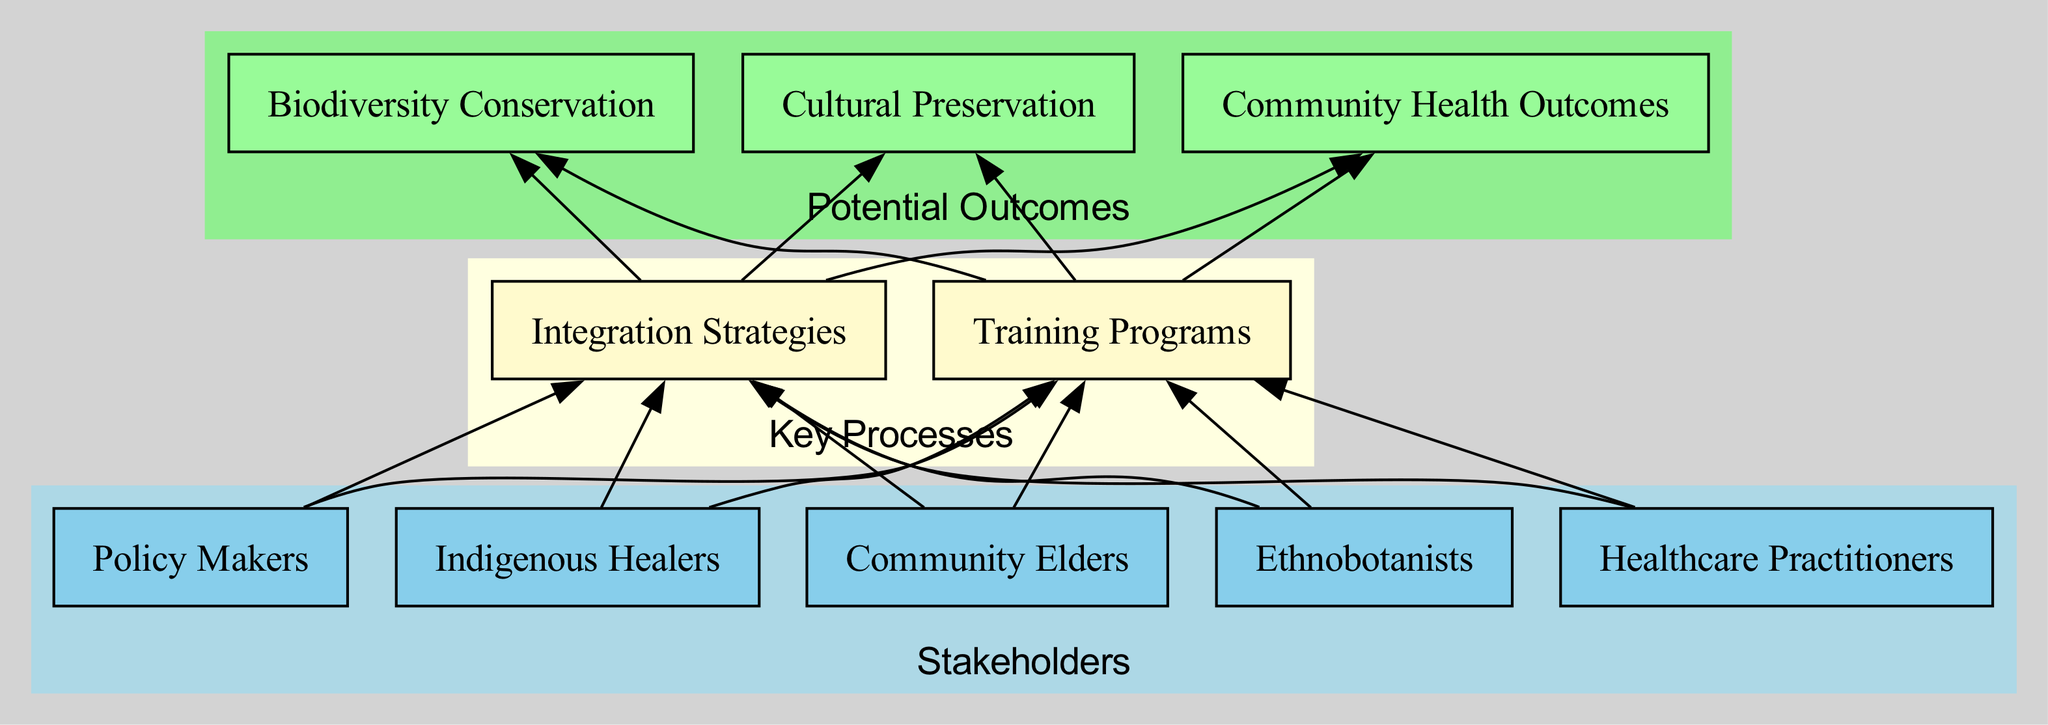What are the stakeholders identified in the diagram? The diagram categorizes certain entities as stakeholders, which include Indigenous Healers, Community Elders, Ethnobotanists, Healthcare Practitioners, and Policy Makers. These elements can be found in the 'Stakeholders' section.
Answer: Indigenous Healers, Community Elders, Ethnobotanists, Healthcare Practitioners, Policy Makers How many potential outcomes are listed in the diagram? The diagram presents three potential outcomes: Community Health Outcomes, Biodiversity Conservation, and Cultural Preservation. By counting these elements found in the 'Potential Outcomes' section, we find a total of three.
Answer: 3 Which key process connects indigenous healers to potential outcomes? The connection from Indigenous Healers occurs through 'Integration Strategies,' which serves as a bridge to the potential outcomes. The edge from 'Indigenous Healers' towards 'Integration Strategies' directs the flow towards potential outcomes.
Answer: Integration Strategies What is the role of Policy Makers in this flow chart? Policy Makers influence the process by developing regulations and guidelines for integrating traditional practices, which connects to key processes and subsequently leads to potential outcomes. Their positioning indicates a guiding function in the integration strategy.
Answer: Regulations and guidelines Which potential outcome directly relates to training programs? The 'Training Programs' key process links to three potential outcomes, but the most direct relation established is with 'Community Health Outcomes,' as training healthcare practitioners enhances health in the community.
Answer: Community Health Outcomes How many edges connect stakeholders to key processes? Each of the five stakeholders connects to the two key processes by one edge each, producing a total of 10 edges connecting stakeholders to key processes. The relationships are structurally laid out showing direct connections.
Answer: 10 What is the significance of the arrow direction in the diagram? The arrow direction illustrates a bottom-up approach, indicating the flow from stakeholders to key processes and then to potential outcomes, emphasizing a directional influence in integrating indigenous practices into healthcare.
Answer: Bottom-up integration What process ensures the continuation of traditional practices for future generations? 'Cultural Preservation' is the potential outcome that ensures traditional practices persist, closely linked through the processes of integration and training that emphasize the importance of indigenous knowledge.
Answer: Cultural Preservation 